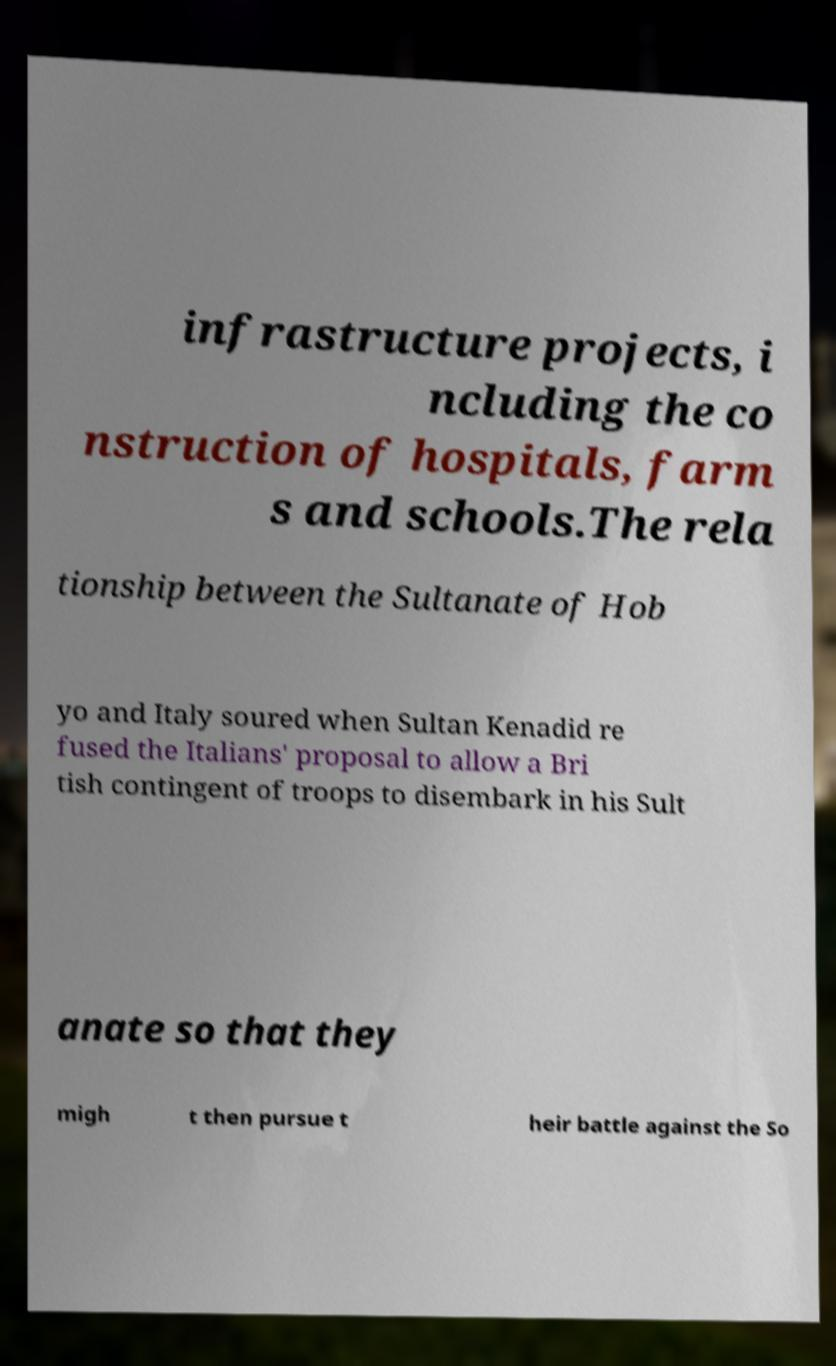Please identify and transcribe the text found in this image. infrastructure projects, i ncluding the co nstruction of hospitals, farm s and schools.The rela tionship between the Sultanate of Hob yo and Italy soured when Sultan Kenadid re fused the Italians' proposal to allow a Bri tish contingent of troops to disembark in his Sult anate so that they migh t then pursue t heir battle against the So 